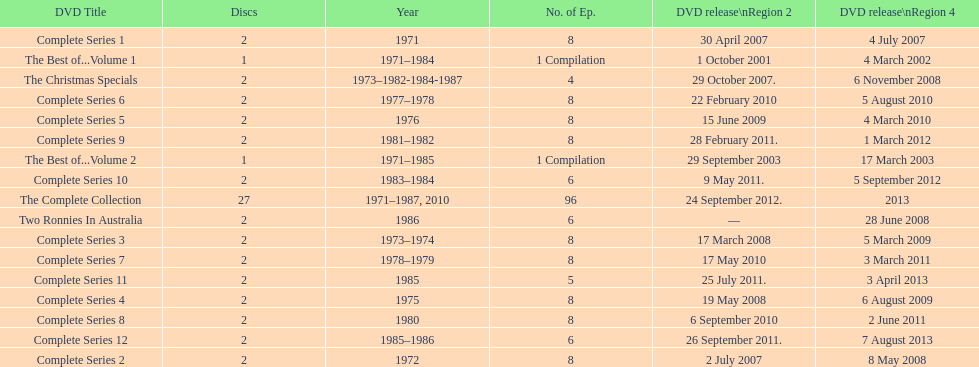How many series had 8 episodes? 9. 